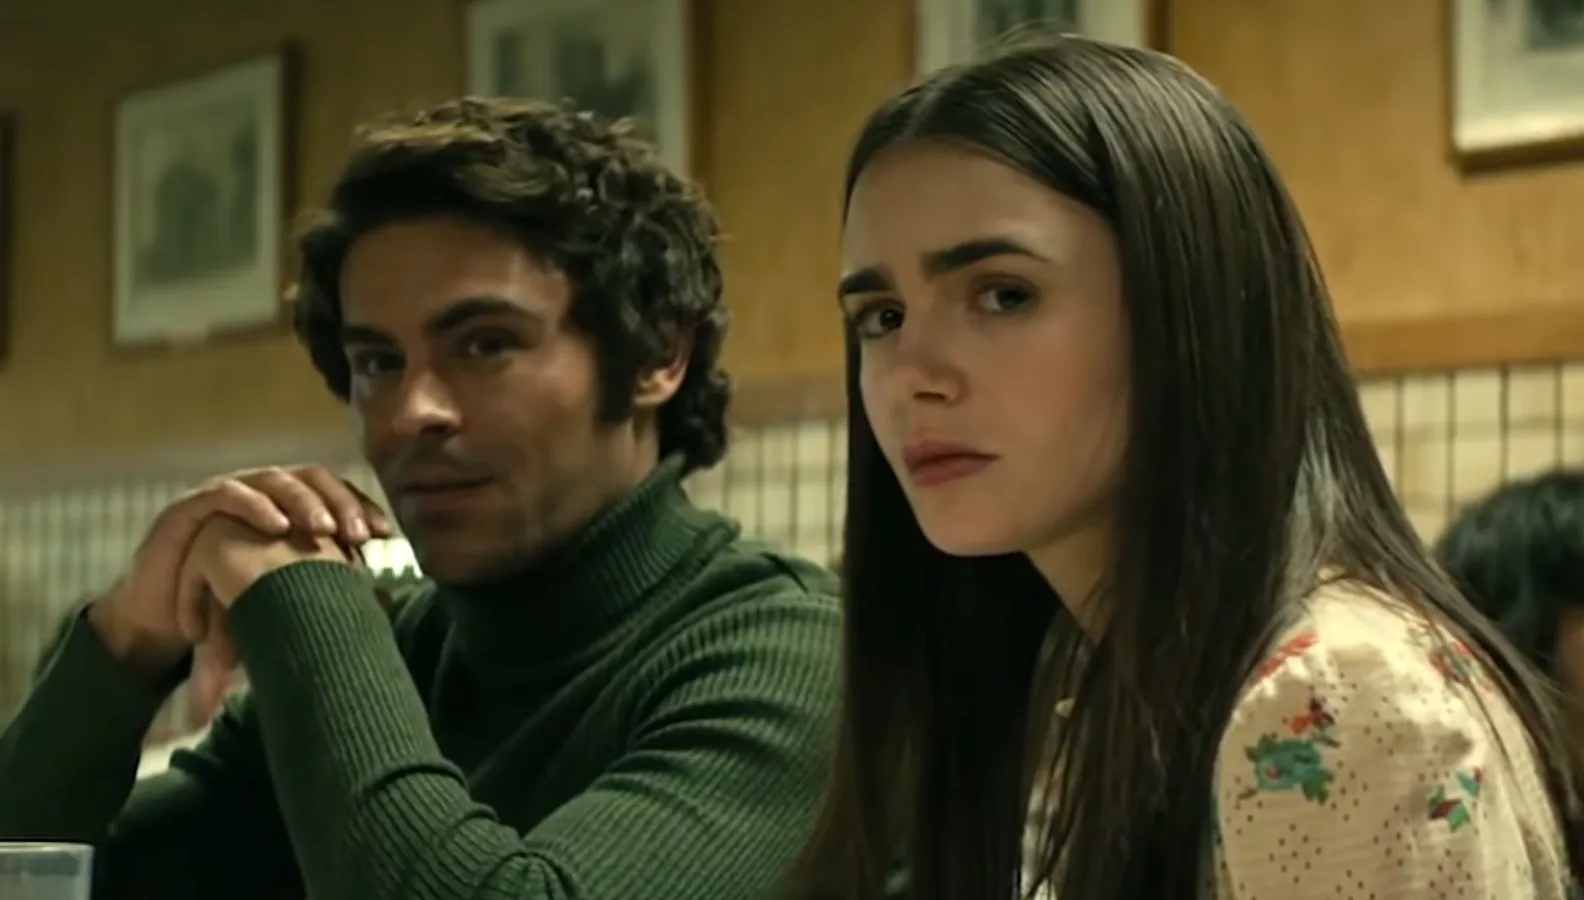Create a whimsical and imaginative scenario for what these characters could be discussing. In a whimsical turn of events, the characters might be discussing an adventure into a magical realm they've recently discovered. The man, with his green turtleneck reminiscent of a forest guardian, could be describing an ancient map leading to hidden lands filled with mystical creatures and enchanted forests. The woman, wearing a blouse adorned with floral patterns, might be a botanist fascinated by the magical flora they will encounter. Their serious expressions reflect the gravity of their mission to uncover the secrets of this otherworldly place, as they embark on a journey where reality bends and the fantastical unfolds. 